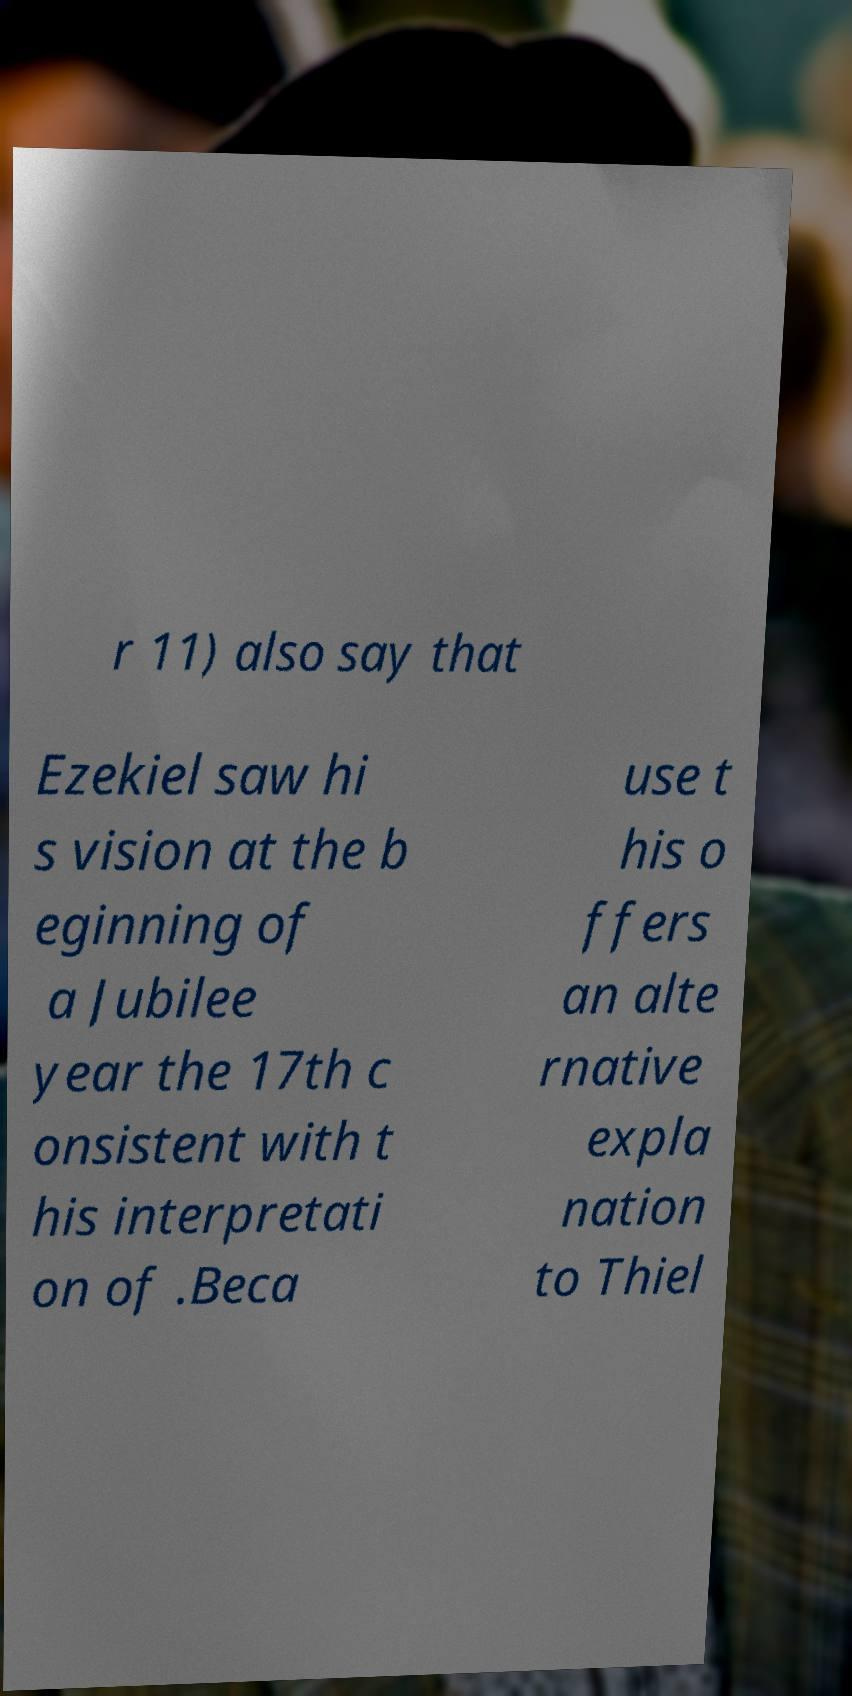Could you extract and type out the text from this image? r 11) also say that Ezekiel saw hi s vision at the b eginning of a Jubilee year the 17th c onsistent with t his interpretati on of .Beca use t his o ffers an alte rnative expla nation to Thiel 